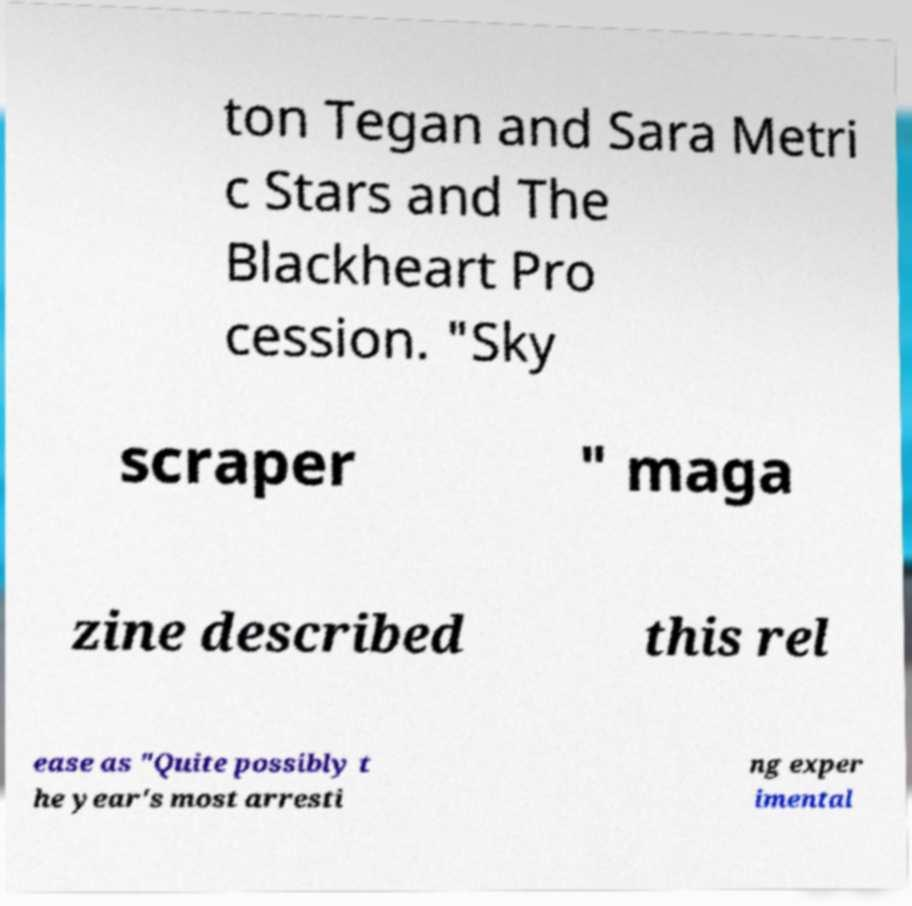What messages or text are displayed in this image? I need them in a readable, typed format. ton Tegan and Sara Metri c Stars and The Blackheart Pro cession. "Sky scraper " maga zine described this rel ease as "Quite possibly t he year's most arresti ng exper imental 